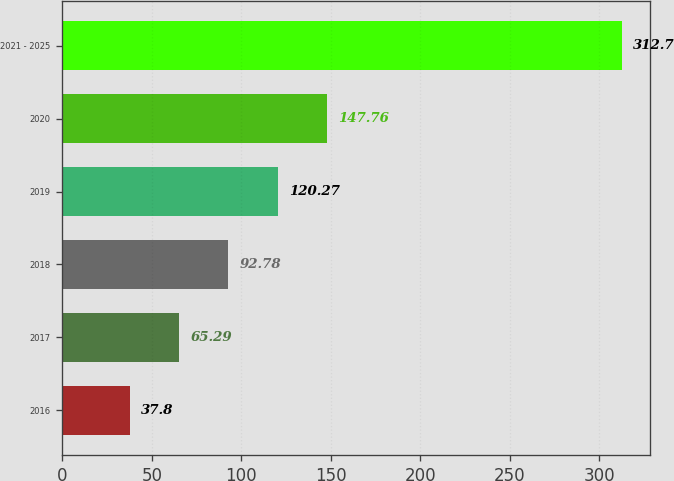<chart> <loc_0><loc_0><loc_500><loc_500><bar_chart><fcel>2016<fcel>2017<fcel>2018<fcel>2019<fcel>2020<fcel>2021 - 2025<nl><fcel>37.8<fcel>65.29<fcel>92.78<fcel>120.27<fcel>147.76<fcel>312.7<nl></chart> 